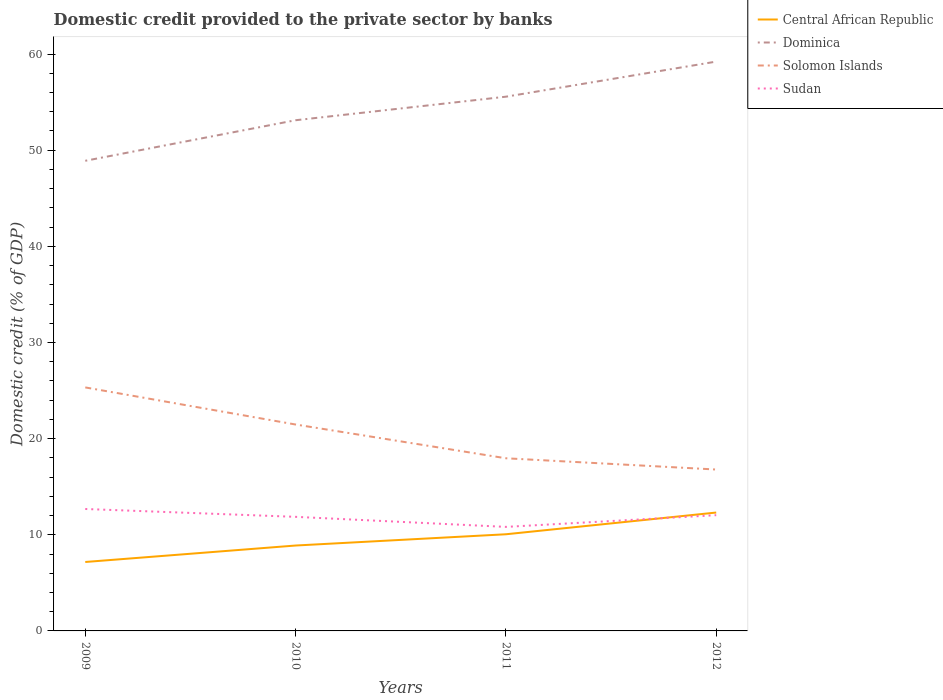Does the line corresponding to Sudan intersect with the line corresponding to Central African Republic?
Your answer should be very brief. Yes. Is the number of lines equal to the number of legend labels?
Offer a very short reply. Yes. Across all years, what is the maximum domestic credit provided to the private sector by banks in Central African Republic?
Ensure brevity in your answer.  7.17. In which year was the domestic credit provided to the private sector by banks in Solomon Islands maximum?
Your answer should be very brief. 2012. What is the total domestic credit provided to the private sector by banks in Sudan in the graph?
Provide a short and direct response. 0.64. What is the difference between the highest and the second highest domestic credit provided to the private sector by banks in Dominica?
Offer a terse response. 10.32. How many lines are there?
Your response must be concise. 4. What is the difference between two consecutive major ticks on the Y-axis?
Make the answer very short. 10. Are the values on the major ticks of Y-axis written in scientific E-notation?
Offer a very short reply. No. Does the graph contain any zero values?
Offer a very short reply. No. Does the graph contain grids?
Keep it short and to the point. No. How many legend labels are there?
Your response must be concise. 4. How are the legend labels stacked?
Provide a succinct answer. Vertical. What is the title of the graph?
Your answer should be very brief. Domestic credit provided to the private sector by banks. What is the label or title of the X-axis?
Provide a short and direct response. Years. What is the label or title of the Y-axis?
Provide a short and direct response. Domestic credit (% of GDP). What is the Domestic credit (% of GDP) of Central African Republic in 2009?
Provide a succinct answer. 7.17. What is the Domestic credit (% of GDP) in Dominica in 2009?
Provide a short and direct response. 48.9. What is the Domestic credit (% of GDP) in Solomon Islands in 2009?
Ensure brevity in your answer.  25.33. What is the Domestic credit (% of GDP) in Sudan in 2009?
Your response must be concise. 12.68. What is the Domestic credit (% of GDP) of Central African Republic in 2010?
Keep it short and to the point. 8.88. What is the Domestic credit (% of GDP) of Dominica in 2010?
Offer a terse response. 53.12. What is the Domestic credit (% of GDP) of Solomon Islands in 2010?
Ensure brevity in your answer.  21.47. What is the Domestic credit (% of GDP) of Sudan in 2010?
Your response must be concise. 11.87. What is the Domestic credit (% of GDP) in Central African Republic in 2011?
Give a very brief answer. 10.05. What is the Domestic credit (% of GDP) of Dominica in 2011?
Provide a short and direct response. 55.56. What is the Domestic credit (% of GDP) of Solomon Islands in 2011?
Your response must be concise. 17.96. What is the Domestic credit (% of GDP) in Sudan in 2011?
Give a very brief answer. 10.82. What is the Domestic credit (% of GDP) of Central African Republic in 2012?
Provide a succinct answer. 12.31. What is the Domestic credit (% of GDP) of Dominica in 2012?
Provide a short and direct response. 59.21. What is the Domestic credit (% of GDP) in Solomon Islands in 2012?
Offer a very short reply. 16.79. What is the Domestic credit (% of GDP) of Sudan in 2012?
Make the answer very short. 12.04. Across all years, what is the maximum Domestic credit (% of GDP) in Central African Republic?
Offer a terse response. 12.31. Across all years, what is the maximum Domestic credit (% of GDP) of Dominica?
Your response must be concise. 59.21. Across all years, what is the maximum Domestic credit (% of GDP) in Solomon Islands?
Ensure brevity in your answer.  25.33. Across all years, what is the maximum Domestic credit (% of GDP) in Sudan?
Your answer should be very brief. 12.68. Across all years, what is the minimum Domestic credit (% of GDP) in Central African Republic?
Provide a short and direct response. 7.17. Across all years, what is the minimum Domestic credit (% of GDP) in Dominica?
Offer a terse response. 48.9. Across all years, what is the minimum Domestic credit (% of GDP) of Solomon Islands?
Provide a short and direct response. 16.79. Across all years, what is the minimum Domestic credit (% of GDP) in Sudan?
Ensure brevity in your answer.  10.82. What is the total Domestic credit (% of GDP) of Central African Republic in the graph?
Your answer should be compact. 38.42. What is the total Domestic credit (% of GDP) in Dominica in the graph?
Your response must be concise. 216.79. What is the total Domestic credit (% of GDP) in Solomon Islands in the graph?
Keep it short and to the point. 81.54. What is the total Domestic credit (% of GDP) of Sudan in the graph?
Provide a succinct answer. 47.41. What is the difference between the Domestic credit (% of GDP) in Central African Republic in 2009 and that in 2010?
Give a very brief answer. -1.71. What is the difference between the Domestic credit (% of GDP) in Dominica in 2009 and that in 2010?
Your answer should be compact. -4.22. What is the difference between the Domestic credit (% of GDP) in Solomon Islands in 2009 and that in 2010?
Your response must be concise. 3.86. What is the difference between the Domestic credit (% of GDP) in Sudan in 2009 and that in 2010?
Make the answer very short. 0.82. What is the difference between the Domestic credit (% of GDP) in Central African Republic in 2009 and that in 2011?
Your response must be concise. -2.88. What is the difference between the Domestic credit (% of GDP) of Dominica in 2009 and that in 2011?
Keep it short and to the point. -6.67. What is the difference between the Domestic credit (% of GDP) of Solomon Islands in 2009 and that in 2011?
Your answer should be compact. 7.37. What is the difference between the Domestic credit (% of GDP) of Sudan in 2009 and that in 2011?
Offer a very short reply. 1.86. What is the difference between the Domestic credit (% of GDP) of Central African Republic in 2009 and that in 2012?
Offer a very short reply. -5.14. What is the difference between the Domestic credit (% of GDP) of Dominica in 2009 and that in 2012?
Keep it short and to the point. -10.32. What is the difference between the Domestic credit (% of GDP) in Solomon Islands in 2009 and that in 2012?
Ensure brevity in your answer.  8.54. What is the difference between the Domestic credit (% of GDP) of Sudan in 2009 and that in 2012?
Ensure brevity in your answer.  0.64. What is the difference between the Domestic credit (% of GDP) in Central African Republic in 2010 and that in 2011?
Offer a terse response. -1.17. What is the difference between the Domestic credit (% of GDP) in Dominica in 2010 and that in 2011?
Give a very brief answer. -2.45. What is the difference between the Domestic credit (% of GDP) of Solomon Islands in 2010 and that in 2011?
Provide a succinct answer. 3.51. What is the difference between the Domestic credit (% of GDP) in Sudan in 2010 and that in 2011?
Provide a succinct answer. 1.04. What is the difference between the Domestic credit (% of GDP) of Central African Republic in 2010 and that in 2012?
Provide a succinct answer. -3.43. What is the difference between the Domestic credit (% of GDP) in Dominica in 2010 and that in 2012?
Keep it short and to the point. -6.1. What is the difference between the Domestic credit (% of GDP) of Solomon Islands in 2010 and that in 2012?
Give a very brief answer. 4.68. What is the difference between the Domestic credit (% of GDP) in Sudan in 2010 and that in 2012?
Your answer should be compact. -0.17. What is the difference between the Domestic credit (% of GDP) of Central African Republic in 2011 and that in 2012?
Your response must be concise. -2.26. What is the difference between the Domestic credit (% of GDP) of Dominica in 2011 and that in 2012?
Offer a terse response. -3.65. What is the difference between the Domestic credit (% of GDP) of Solomon Islands in 2011 and that in 2012?
Your response must be concise. 1.17. What is the difference between the Domestic credit (% of GDP) of Sudan in 2011 and that in 2012?
Offer a terse response. -1.22. What is the difference between the Domestic credit (% of GDP) of Central African Republic in 2009 and the Domestic credit (% of GDP) of Dominica in 2010?
Provide a short and direct response. -45.95. What is the difference between the Domestic credit (% of GDP) in Central African Republic in 2009 and the Domestic credit (% of GDP) in Solomon Islands in 2010?
Provide a succinct answer. -14.3. What is the difference between the Domestic credit (% of GDP) of Central African Republic in 2009 and the Domestic credit (% of GDP) of Sudan in 2010?
Provide a short and direct response. -4.7. What is the difference between the Domestic credit (% of GDP) of Dominica in 2009 and the Domestic credit (% of GDP) of Solomon Islands in 2010?
Offer a very short reply. 27.43. What is the difference between the Domestic credit (% of GDP) of Dominica in 2009 and the Domestic credit (% of GDP) of Sudan in 2010?
Ensure brevity in your answer.  37.03. What is the difference between the Domestic credit (% of GDP) of Solomon Islands in 2009 and the Domestic credit (% of GDP) of Sudan in 2010?
Offer a terse response. 13.46. What is the difference between the Domestic credit (% of GDP) of Central African Republic in 2009 and the Domestic credit (% of GDP) of Dominica in 2011?
Provide a succinct answer. -48.39. What is the difference between the Domestic credit (% of GDP) of Central African Republic in 2009 and the Domestic credit (% of GDP) of Solomon Islands in 2011?
Ensure brevity in your answer.  -10.79. What is the difference between the Domestic credit (% of GDP) in Central African Republic in 2009 and the Domestic credit (% of GDP) in Sudan in 2011?
Your answer should be compact. -3.65. What is the difference between the Domestic credit (% of GDP) of Dominica in 2009 and the Domestic credit (% of GDP) of Solomon Islands in 2011?
Give a very brief answer. 30.94. What is the difference between the Domestic credit (% of GDP) of Dominica in 2009 and the Domestic credit (% of GDP) of Sudan in 2011?
Offer a very short reply. 38.08. What is the difference between the Domestic credit (% of GDP) of Solomon Islands in 2009 and the Domestic credit (% of GDP) of Sudan in 2011?
Offer a very short reply. 14.51. What is the difference between the Domestic credit (% of GDP) of Central African Republic in 2009 and the Domestic credit (% of GDP) of Dominica in 2012?
Provide a short and direct response. -52.05. What is the difference between the Domestic credit (% of GDP) of Central African Republic in 2009 and the Domestic credit (% of GDP) of Solomon Islands in 2012?
Your answer should be very brief. -9.62. What is the difference between the Domestic credit (% of GDP) in Central African Republic in 2009 and the Domestic credit (% of GDP) in Sudan in 2012?
Provide a short and direct response. -4.87. What is the difference between the Domestic credit (% of GDP) of Dominica in 2009 and the Domestic credit (% of GDP) of Solomon Islands in 2012?
Your response must be concise. 32.11. What is the difference between the Domestic credit (% of GDP) in Dominica in 2009 and the Domestic credit (% of GDP) in Sudan in 2012?
Provide a short and direct response. 36.86. What is the difference between the Domestic credit (% of GDP) in Solomon Islands in 2009 and the Domestic credit (% of GDP) in Sudan in 2012?
Make the answer very short. 13.29. What is the difference between the Domestic credit (% of GDP) in Central African Republic in 2010 and the Domestic credit (% of GDP) in Dominica in 2011?
Provide a short and direct response. -46.68. What is the difference between the Domestic credit (% of GDP) of Central African Republic in 2010 and the Domestic credit (% of GDP) of Solomon Islands in 2011?
Your response must be concise. -9.08. What is the difference between the Domestic credit (% of GDP) of Central African Republic in 2010 and the Domestic credit (% of GDP) of Sudan in 2011?
Offer a very short reply. -1.94. What is the difference between the Domestic credit (% of GDP) in Dominica in 2010 and the Domestic credit (% of GDP) in Solomon Islands in 2011?
Keep it short and to the point. 35.16. What is the difference between the Domestic credit (% of GDP) in Dominica in 2010 and the Domestic credit (% of GDP) in Sudan in 2011?
Provide a short and direct response. 42.3. What is the difference between the Domestic credit (% of GDP) of Solomon Islands in 2010 and the Domestic credit (% of GDP) of Sudan in 2011?
Your answer should be compact. 10.65. What is the difference between the Domestic credit (% of GDP) of Central African Republic in 2010 and the Domestic credit (% of GDP) of Dominica in 2012?
Provide a short and direct response. -50.33. What is the difference between the Domestic credit (% of GDP) in Central African Republic in 2010 and the Domestic credit (% of GDP) in Solomon Islands in 2012?
Your answer should be compact. -7.9. What is the difference between the Domestic credit (% of GDP) in Central African Republic in 2010 and the Domestic credit (% of GDP) in Sudan in 2012?
Give a very brief answer. -3.16. What is the difference between the Domestic credit (% of GDP) in Dominica in 2010 and the Domestic credit (% of GDP) in Solomon Islands in 2012?
Ensure brevity in your answer.  36.33. What is the difference between the Domestic credit (% of GDP) in Dominica in 2010 and the Domestic credit (% of GDP) in Sudan in 2012?
Your answer should be compact. 41.08. What is the difference between the Domestic credit (% of GDP) in Solomon Islands in 2010 and the Domestic credit (% of GDP) in Sudan in 2012?
Your answer should be compact. 9.43. What is the difference between the Domestic credit (% of GDP) in Central African Republic in 2011 and the Domestic credit (% of GDP) in Dominica in 2012?
Your answer should be compact. -49.16. What is the difference between the Domestic credit (% of GDP) of Central African Republic in 2011 and the Domestic credit (% of GDP) of Solomon Islands in 2012?
Your answer should be compact. -6.73. What is the difference between the Domestic credit (% of GDP) in Central African Republic in 2011 and the Domestic credit (% of GDP) in Sudan in 2012?
Ensure brevity in your answer.  -1.99. What is the difference between the Domestic credit (% of GDP) in Dominica in 2011 and the Domestic credit (% of GDP) in Solomon Islands in 2012?
Provide a succinct answer. 38.78. What is the difference between the Domestic credit (% of GDP) in Dominica in 2011 and the Domestic credit (% of GDP) in Sudan in 2012?
Keep it short and to the point. 43.53. What is the difference between the Domestic credit (% of GDP) of Solomon Islands in 2011 and the Domestic credit (% of GDP) of Sudan in 2012?
Offer a terse response. 5.92. What is the average Domestic credit (% of GDP) in Central African Republic per year?
Offer a terse response. 9.6. What is the average Domestic credit (% of GDP) in Dominica per year?
Provide a succinct answer. 54.2. What is the average Domestic credit (% of GDP) of Solomon Islands per year?
Make the answer very short. 20.38. What is the average Domestic credit (% of GDP) of Sudan per year?
Offer a terse response. 11.85. In the year 2009, what is the difference between the Domestic credit (% of GDP) of Central African Republic and Domestic credit (% of GDP) of Dominica?
Offer a very short reply. -41.73. In the year 2009, what is the difference between the Domestic credit (% of GDP) of Central African Republic and Domestic credit (% of GDP) of Solomon Islands?
Your answer should be very brief. -18.16. In the year 2009, what is the difference between the Domestic credit (% of GDP) of Central African Republic and Domestic credit (% of GDP) of Sudan?
Ensure brevity in your answer.  -5.51. In the year 2009, what is the difference between the Domestic credit (% of GDP) of Dominica and Domestic credit (% of GDP) of Solomon Islands?
Offer a terse response. 23.57. In the year 2009, what is the difference between the Domestic credit (% of GDP) in Dominica and Domestic credit (% of GDP) in Sudan?
Make the answer very short. 36.22. In the year 2009, what is the difference between the Domestic credit (% of GDP) in Solomon Islands and Domestic credit (% of GDP) in Sudan?
Offer a very short reply. 12.64. In the year 2010, what is the difference between the Domestic credit (% of GDP) of Central African Republic and Domestic credit (% of GDP) of Dominica?
Ensure brevity in your answer.  -44.23. In the year 2010, what is the difference between the Domestic credit (% of GDP) in Central African Republic and Domestic credit (% of GDP) in Solomon Islands?
Provide a short and direct response. -12.59. In the year 2010, what is the difference between the Domestic credit (% of GDP) of Central African Republic and Domestic credit (% of GDP) of Sudan?
Make the answer very short. -2.98. In the year 2010, what is the difference between the Domestic credit (% of GDP) of Dominica and Domestic credit (% of GDP) of Solomon Islands?
Provide a succinct answer. 31.65. In the year 2010, what is the difference between the Domestic credit (% of GDP) of Dominica and Domestic credit (% of GDP) of Sudan?
Provide a succinct answer. 41.25. In the year 2010, what is the difference between the Domestic credit (% of GDP) of Solomon Islands and Domestic credit (% of GDP) of Sudan?
Keep it short and to the point. 9.6. In the year 2011, what is the difference between the Domestic credit (% of GDP) in Central African Republic and Domestic credit (% of GDP) in Dominica?
Give a very brief answer. -45.51. In the year 2011, what is the difference between the Domestic credit (% of GDP) of Central African Republic and Domestic credit (% of GDP) of Solomon Islands?
Offer a very short reply. -7.9. In the year 2011, what is the difference between the Domestic credit (% of GDP) of Central African Republic and Domestic credit (% of GDP) of Sudan?
Offer a very short reply. -0.77. In the year 2011, what is the difference between the Domestic credit (% of GDP) in Dominica and Domestic credit (% of GDP) in Solomon Islands?
Provide a succinct answer. 37.61. In the year 2011, what is the difference between the Domestic credit (% of GDP) in Dominica and Domestic credit (% of GDP) in Sudan?
Your response must be concise. 44.74. In the year 2011, what is the difference between the Domestic credit (% of GDP) in Solomon Islands and Domestic credit (% of GDP) in Sudan?
Keep it short and to the point. 7.14. In the year 2012, what is the difference between the Domestic credit (% of GDP) of Central African Republic and Domestic credit (% of GDP) of Dominica?
Ensure brevity in your answer.  -46.9. In the year 2012, what is the difference between the Domestic credit (% of GDP) in Central African Republic and Domestic credit (% of GDP) in Solomon Islands?
Keep it short and to the point. -4.47. In the year 2012, what is the difference between the Domestic credit (% of GDP) in Central African Republic and Domestic credit (% of GDP) in Sudan?
Your answer should be very brief. 0.27. In the year 2012, what is the difference between the Domestic credit (% of GDP) of Dominica and Domestic credit (% of GDP) of Solomon Islands?
Keep it short and to the point. 42.43. In the year 2012, what is the difference between the Domestic credit (% of GDP) of Dominica and Domestic credit (% of GDP) of Sudan?
Keep it short and to the point. 47.18. In the year 2012, what is the difference between the Domestic credit (% of GDP) of Solomon Islands and Domestic credit (% of GDP) of Sudan?
Provide a succinct answer. 4.75. What is the ratio of the Domestic credit (% of GDP) in Central African Republic in 2009 to that in 2010?
Your response must be concise. 0.81. What is the ratio of the Domestic credit (% of GDP) in Dominica in 2009 to that in 2010?
Provide a short and direct response. 0.92. What is the ratio of the Domestic credit (% of GDP) in Solomon Islands in 2009 to that in 2010?
Your answer should be very brief. 1.18. What is the ratio of the Domestic credit (% of GDP) of Sudan in 2009 to that in 2010?
Offer a terse response. 1.07. What is the ratio of the Domestic credit (% of GDP) in Central African Republic in 2009 to that in 2011?
Ensure brevity in your answer.  0.71. What is the ratio of the Domestic credit (% of GDP) of Solomon Islands in 2009 to that in 2011?
Keep it short and to the point. 1.41. What is the ratio of the Domestic credit (% of GDP) in Sudan in 2009 to that in 2011?
Your answer should be very brief. 1.17. What is the ratio of the Domestic credit (% of GDP) of Central African Republic in 2009 to that in 2012?
Offer a terse response. 0.58. What is the ratio of the Domestic credit (% of GDP) of Dominica in 2009 to that in 2012?
Keep it short and to the point. 0.83. What is the ratio of the Domestic credit (% of GDP) of Solomon Islands in 2009 to that in 2012?
Make the answer very short. 1.51. What is the ratio of the Domestic credit (% of GDP) in Sudan in 2009 to that in 2012?
Provide a short and direct response. 1.05. What is the ratio of the Domestic credit (% of GDP) of Central African Republic in 2010 to that in 2011?
Keep it short and to the point. 0.88. What is the ratio of the Domestic credit (% of GDP) of Dominica in 2010 to that in 2011?
Ensure brevity in your answer.  0.96. What is the ratio of the Domestic credit (% of GDP) of Solomon Islands in 2010 to that in 2011?
Keep it short and to the point. 1.2. What is the ratio of the Domestic credit (% of GDP) in Sudan in 2010 to that in 2011?
Provide a short and direct response. 1.1. What is the ratio of the Domestic credit (% of GDP) in Central African Republic in 2010 to that in 2012?
Give a very brief answer. 0.72. What is the ratio of the Domestic credit (% of GDP) in Dominica in 2010 to that in 2012?
Give a very brief answer. 0.9. What is the ratio of the Domestic credit (% of GDP) in Solomon Islands in 2010 to that in 2012?
Your response must be concise. 1.28. What is the ratio of the Domestic credit (% of GDP) in Sudan in 2010 to that in 2012?
Provide a short and direct response. 0.99. What is the ratio of the Domestic credit (% of GDP) in Central African Republic in 2011 to that in 2012?
Give a very brief answer. 0.82. What is the ratio of the Domestic credit (% of GDP) of Dominica in 2011 to that in 2012?
Your response must be concise. 0.94. What is the ratio of the Domestic credit (% of GDP) of Solomon Islands in 2011 to that in 2012?
Provide a short and direct response. 1.07. What is the ratio of the Domestic credit (% of GDP) in Sudan in 2011 to that in 2012?
Make the answer very short. 0.9. What is the difference between the highest and the second highest Domestic credit (% of GDP) in Central African Republic?
Your answer should be very brief. 2.26. What is the difference between the highest and the second highest Domestic credit (% of GDP) of Dominica?
Your answer should be very brief. 3.65. What is the difference between the highest and the second highest Domestic credit (% of GDP) in Solomon Islands?
Ensure brevity in your answer.  3.86. What is the difference between the highest and the second highest Domestic credit (% of GDP) in Sudan?
Offer a terse response. 0.64. What is the difference between the highest and the lowest Domestic credit (% of GDP) of Central African Republic?
Give a very brief answer. 5.14. What is the difference between the highest and the lowest Domestic credit (% of GDP) in Dominica?
Offer a very short reply. 10.32. What is the difference between the highest and the lowest Domestic credit (% of GDP) in Solomon Islands?
Offer a very short reply. 8.54. What is the difference between the highest and the lowest Domestic credit (% of GDP) of Sudan?
Your answer should be compact. 1.86. 